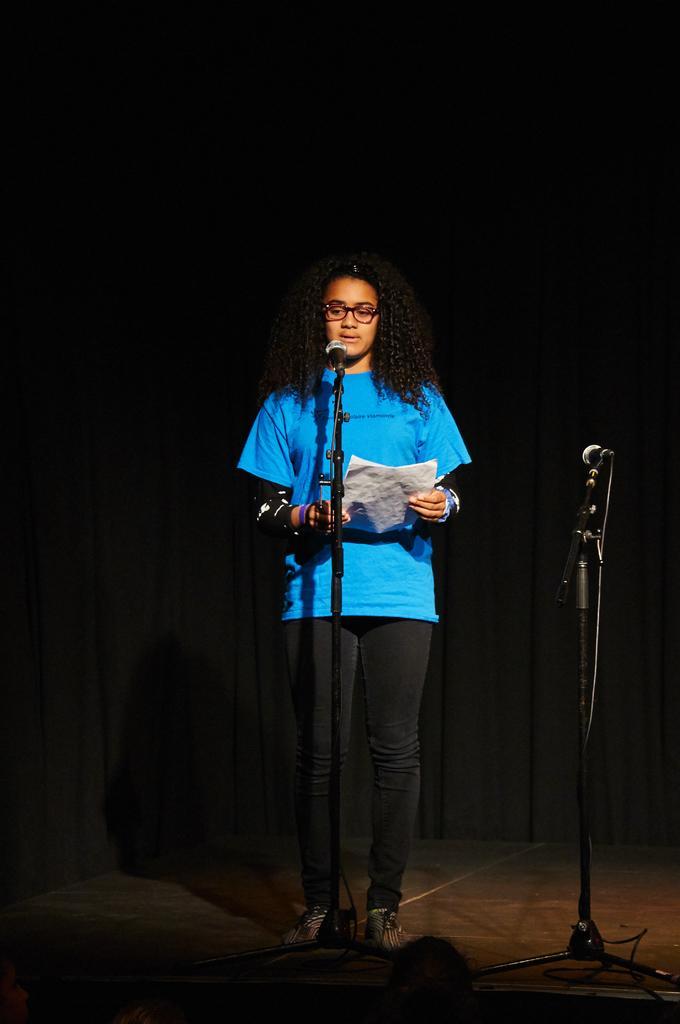In one or two sentences, can you explain what this image depicts? In this image we can see a person is holding papers and standing on the floor. Here we can see miles and cables. In the background we can see a curtain. At the bottom of the image it is dark. 